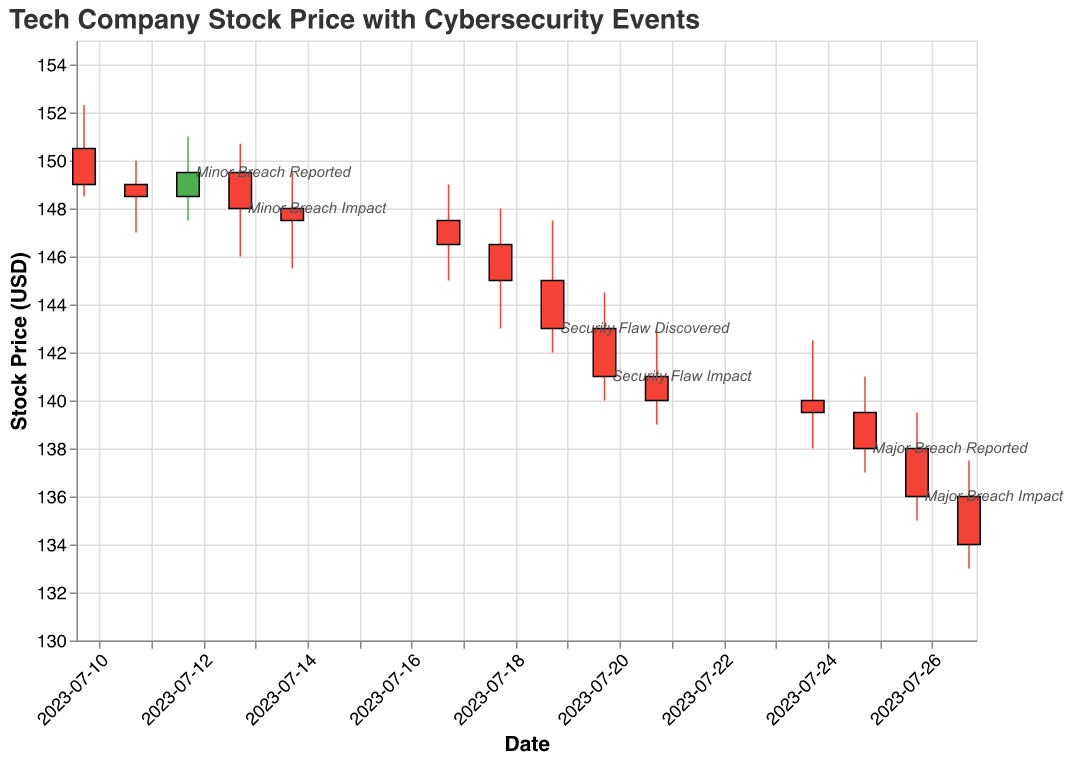How many times does the stock price close lower than it opened? To determine this, we analyze each candlestick's color on the plot. If the candlestick is red, the stock closed lower than it opened. We count the number of red candlesticks.
Answer: 9 What is the highest stock price reached between July 10 and July 27, 2023? The 'High' value represents the highest stock price reached on a given day. By looking at the 'High' values, the maximum is 152.30, as seen on July 10.
Answer: 152.30 How did the stock price respond to the "Major Breach Reported" event on July 25, 2023? The "Major Breach Reported" event is on July 25, where the stock closed at 138.00. The following day, the stock price decreased, closing at 136.00 on July 26.
Answer: It decreased Between the "Minor Breach Reported" on July 12 and the "Security Flaw Discovered" on July 19, what was the overall trend in the closing stock price? We need to compare the closing price on July 12 (149.50) with the closing price on July 19 (143.00). The stock price shows a decreasing trend.
Answer: Decreasing Which event caused the most significant drop in closing stock price? To find this, calculate the daily closing price difference and identify the largest drop. The most significant drop occurred from July 18 (145.00) to July 19 (143.00), during the "Security Flaw Discovered" event.
Answer: Security Flaw Discovered What was the difference in closing stock prices between July 10 and July 27, 2023? The closing price on July 10 was 149.00, and on July 27, it was 134.00. The difference is calculated as 149.00 - 134.00.
Answer: 15.00 How does the volume of stock trades correlate with cybersecurity events? Higher volumes correspond to significant cybersecurity events, like the "Security Flaw Impact" on July 20 (6000000) and "Major Breach Impact" on July 26 (6200000), indicating that major events lead to increased trading activity.
Answer: Increase during major events Compare the closing prices on July 13 ("Minor Breach Impact") and July 20 ("Security Flaw Impact"). Which day had a lower closing price? On July 13, the closing price was 148.00, and on July 20, it was 141.00. Comparing these values, July 20 had a lower closing price.
Answer: July 20 Calculate the average closing price during the "No Breach" periods. Identify closing prices during "No Breach" days: 149.00, 148.50, 147.50, 146.50, 145.00, 140.00, 139.50, and 134.00. Sum these prices (1150.00) and divide by the number of days (8).
Answer: 143.75 